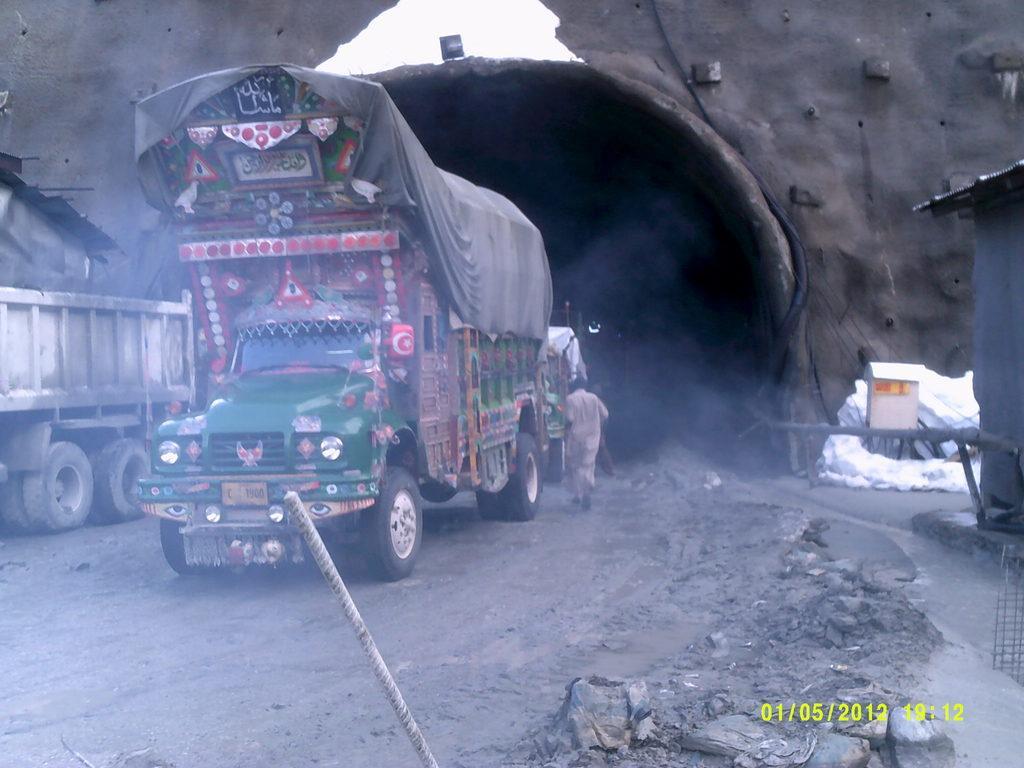Can you describe this image briefly? In this image there is the sky towards the top of the image, there are walls, there is a light, there are vehicles on the road, there is a man running, there is a building towards the right of the image, there is an object towards the right of the image, there are numbers towards the bottom of the image, there is an object towards the bottom of the image, there is a building towards the left of the image, there are objects on the ground. 